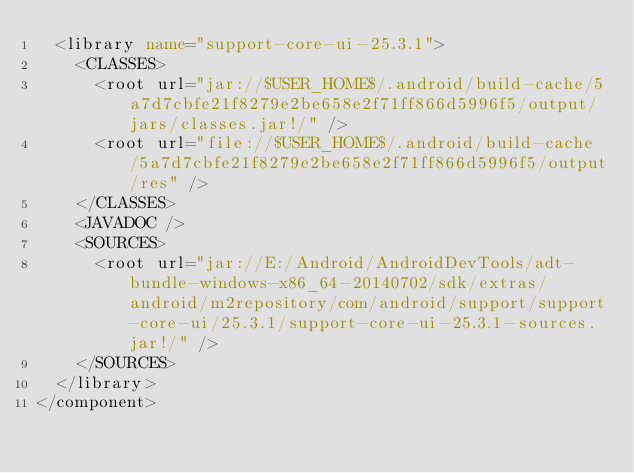Convert code to text. <code><loc_0><loc_0><loc_500><loc_500><_XML_>  <library name="support-core-ui-25.3.1">
    <CLASSES>
      <root url="jar://$USER_HOME$/.android/build-cache/5a7d7cbfe21f8279e2be658e2f71ff866d5996f5/output/jars/classes.jar!/" />
      <root url="file://$USER_HOME$/.android/build-cache/5a7d7cbfe21f8279e2be658e2f71ff866d5996f5/output/res" />
    </CLASSES>
    <JAVADOC />
    <SOURCES>
      <root url="jar://E:/Android/AndroidDevTools/adt-bundle-windows-x86_64-20140702/sdk/extras/android/m2repository/com/android/support/support-core-ui/25.3.1/support-core-ui-25.3.1-sources.jar!/" />
    </SOURCES>
  </library>
</component></code> 